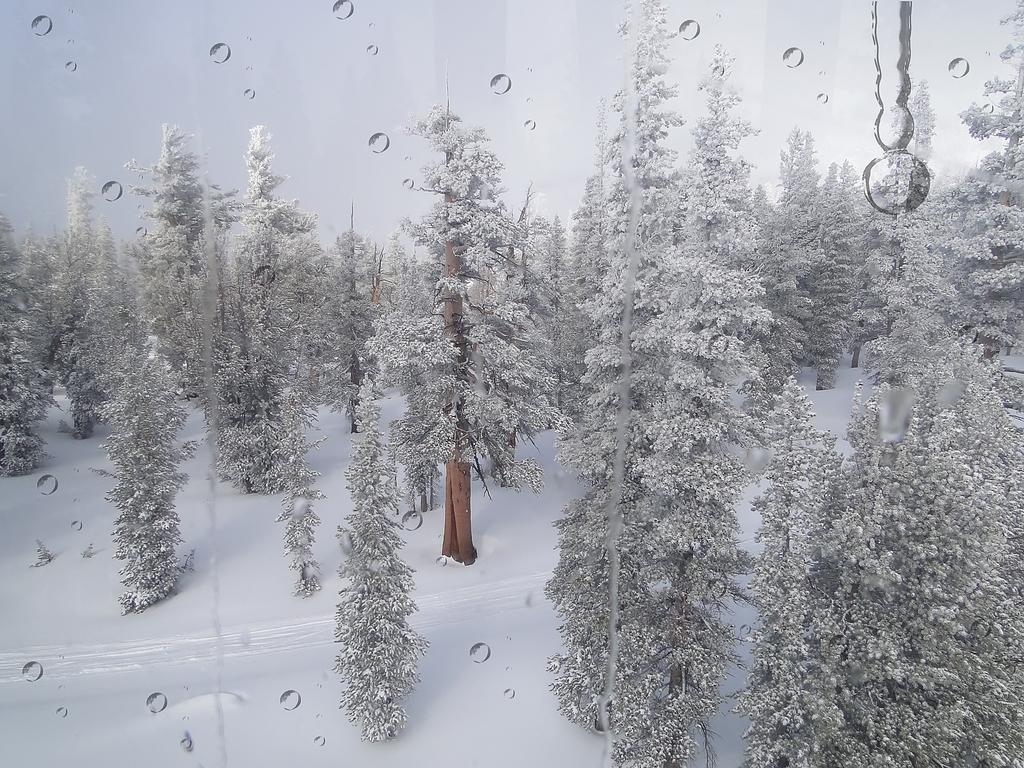In one or two sentences, can you explain what this image depicts? In the picture we can see a poster on it, we can see a some trees on the snow surface and some snow on it and to the poster we can see some water droplets. 